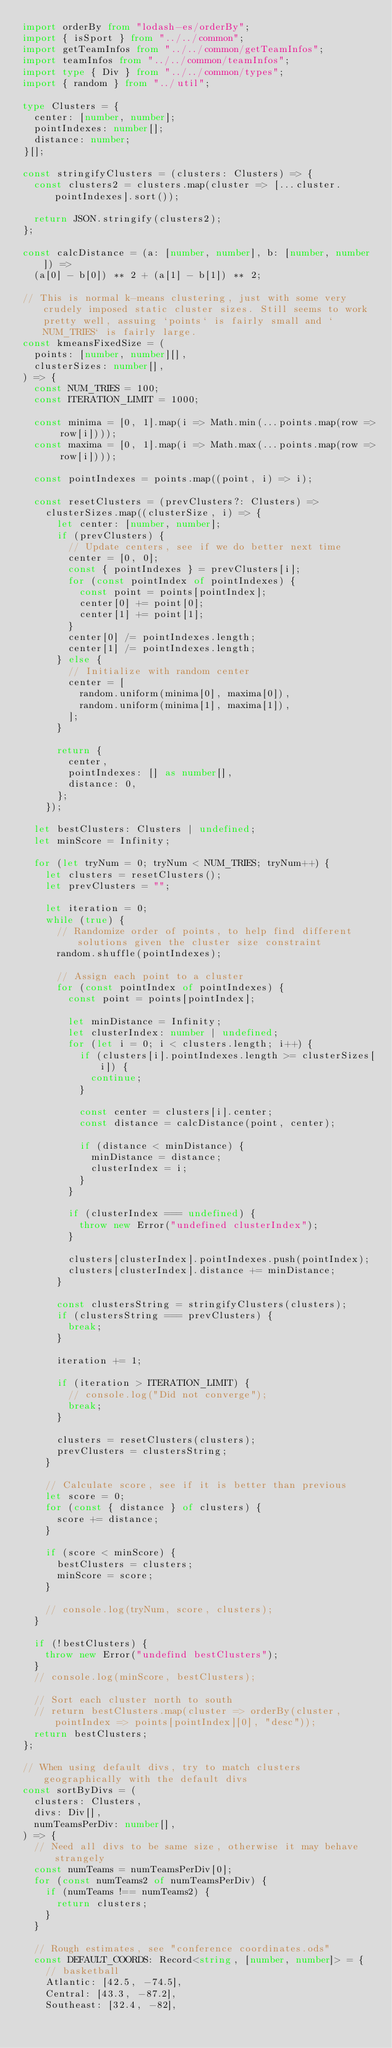Convert code to text. <code><loc_0><loc_0><loc_500><loc_500><_TypeScript_>import orderBy from "lodash-es/orderBy";
import { isSport } from "../../common";
import getTeamInfos from "../../common/getTeamInfos";
import teamInfos from "../../common/teamInfos";
import type { Div } from "../../common/types";
import { random } from "../util";

type Clusters = {
	center: [number, number];
	pointIndexes: number[];
	distance: number;
}[];

const stringifyClusters = (clusters: Clusters) => {
	const clusters2 = clusters.map(cluster => [...cluster.pointIndexes].sort());

	return JSON.stringify(clusters2);
};

const calcDistance = (a: [number, number], b: [number, number]) =>
	(a[0] - b[0]) ** 2 + (a[1] - b[1]) ** 2;

// This is normal k-means clustering, just with some very crudely imposed static cluster sizes. Still seems to work pretty well, assuing `points` is fairly small and `NUM_TRIES` is fairly large.
const kmeansFixedSize = (
	points: [number, number][],
	clusterSizes: number[],
) => {
	const NUM_TRIES = 100;
	const ITERATION_LIMIT = 1000;

	const minima = [0, 1].map(i => Math.min(...points.map(row => row[i])));
	const maxima = [0, 1].map(i => Math.max(...points.map(row => row[i])));

	const pointIndexes = points.map((point, i) => i);

	const resetClusters = (prevClusters?: Clusters) =>
		clusterSizes.map((clusterSize, i) => {
			let center: [number, number];
			if (prevClusters) {
				// Update centers, see if we do better next time
				center = [0, 0];
				const { pointIndexes } = prevClusters[i];
				for (const pointIndex of pointIndexes) {
					const point = points[pointIndex];
					center[0] += point[0];
					center[1] += point[1];
				}
				center[0] /= pointIndexes.length;
				center[1] /= pointIndexes.length;
			} else {
				// Initialize with random center
				center = [
					random.uniform(minima[0], maxima[0]),
					random.uniform(minima[1], maxima[1]),
				];
			}

			return {
				center,
				pointIndexes: [] as number[],
				distance: 0,
			};
		});

	let bestClusters: Clusters | undefined;
	let minScore = Infinity;

	for (let tryNum = 0; tryNum < NUM_TRIES; tryNum++) {
		let clusters = resetClusters();
		let prevClusters = "";

		let iteration = 0;
		while (true) {
			// Randomize order of points, to help find different solutions given the cluster size constraint
			random.shuffle(pointIndexes);

			// Assign each point to a cluster
			for (const pointIndex of pointIndexes) {
				const point = points[pointIndex];

				let minDistance = Infinity;
				let clusterIndex: number | undefined;
				for (let i = 0; i < clusters.length; i++) {
					if (clusters[i].pointIndexes.length >= clusterSizes[i]) {
						continue;
					}

					const center = clusters[i].center;
					const distance = calcDistance(point, center);

					if (distance < minDistance) {
						minDistance = distance;
						clusterIndex = i;
					}
				}

				if (clusterIndex === undefined) {
					throw new Error("undefined clusterIndex");
				}

				clusters[clusterIndex].pointIndexes.push(pointIndex);
				clusters[clusterIndex].distance += minDistance;
			}

			const clustersString = stringifyClusters(clusters);
			if (clustersString === prevClusters) {
				break;
			}

			iteration += 1;

			if (iteration > ITERATION_LIMIT) {
				// console.log("Did not converge");
				break;
			}

			clusters = resetClusters(clusters);
			prevClusters = clustersString;
		}

		// Calculate score, see if it is better than previous
		let score = 0;
		for (const { distance } of clusters) {
			score += distance;
		}

		if (score < minScore) {
			bestClusters = clusters;
			minScore = score;
		}

		// console.log(tryNum, score, clusters);
	}

	if (!bestClusters) {
		throw new Error("undefind bestClusters");
	}
	// console.log(minScore, bestClusters);

	// Sort each cluster north to south
	// return bestClusters.map(cluster => orderBy(cluster, pointIndex => points[pointIndex][0], "desc"));
	return bestClusters;
};

// When using default divs, try to match clusters geographically with the default divs
const sortByDivs = (
	clusters: Clusters,
	divs: Div[],
	numTeamsPerDiv: number[],
) => {
	// Need all divs to be same size, otherwise it may behave strangely
	const numTeams = numTeamsPerDiv[0];
	for (const numTeams2 of numTeamsPerDiv) {
		if (numTeams !== numTeams2) {
			return clusters;
		}
	}

	// Rough estimates, see "conference coordinates.ods"
	const DEFAULT_COORDS: Record<string, [number, number]> = {
		// basketball
		Atlantic: [42.5, -74.5],
		Central: [43.3, -87.2],
		Southeast: [32.4, -82],</code> 